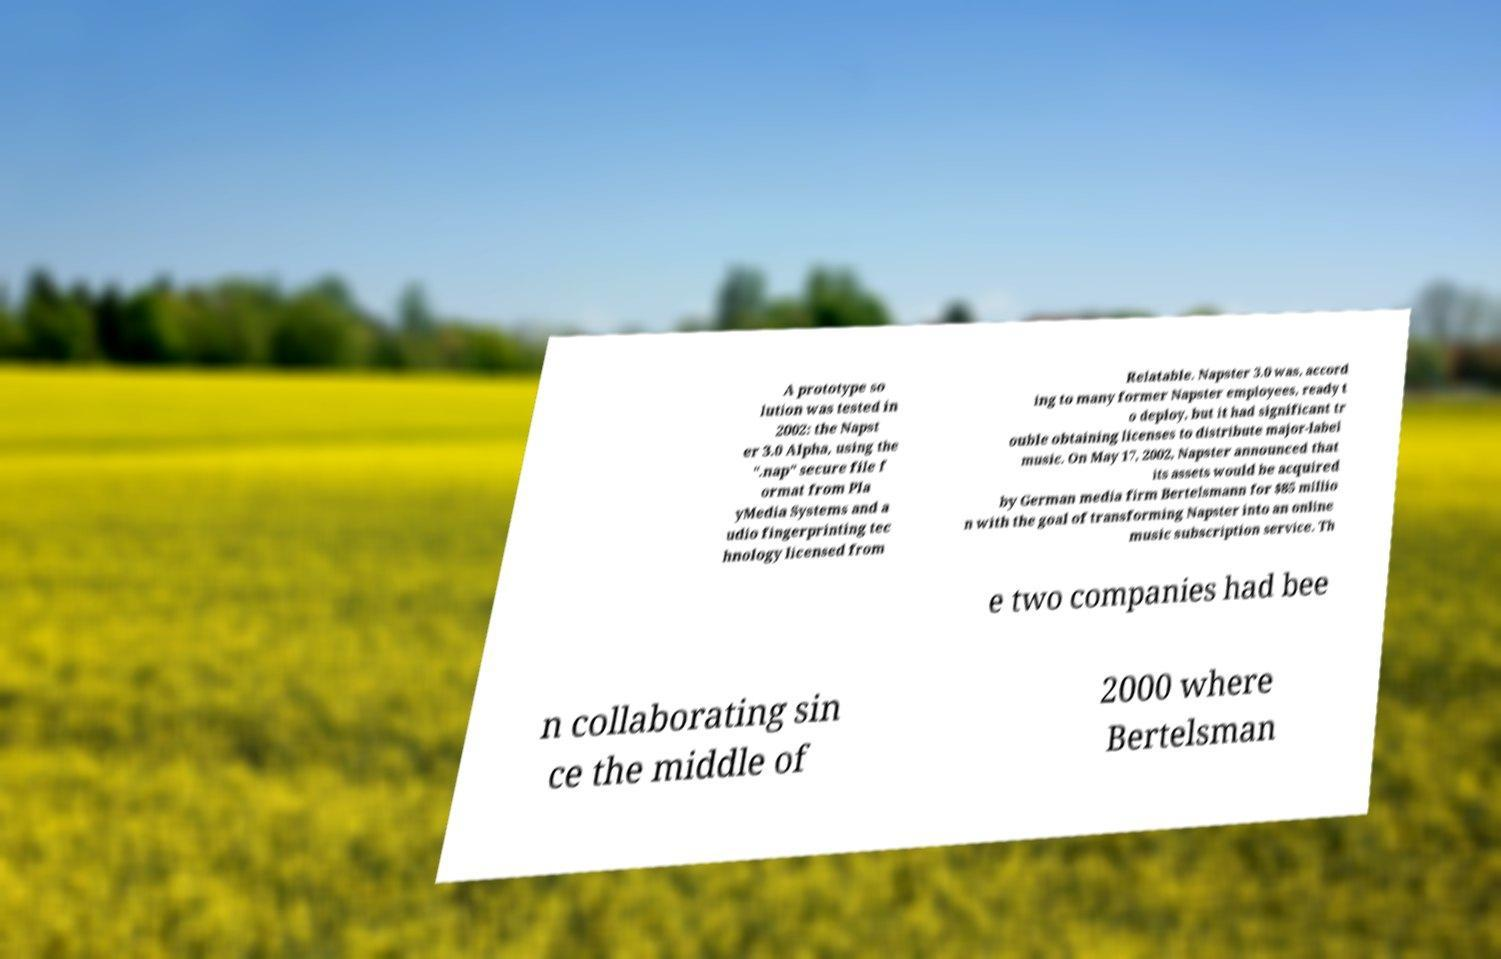There's text embedded in this image that I need extracted. Can you transcribe it verbatim? A prototype so lution was tested in 2002: the Napst er 3.0 Alpha, using the ".nap" secure file f ormat from Pla yMedia Systems and a udio fingerprinting tec hnology licensed from Relatable. Napster 3.0 was, accord ing to many former Napster employees, ready t o deploy, but it had significant tr ouble obtaining licenses to distribute major-label music. On May 17, 2002, Napster announced that its assets would be acquired by German media firm Bertelsmann for $85 millio n with the goal of transforming Napster into an online music subscription service. Th e two companies had bee n collaborating sin ce the middle of 2000 where Bertelsman 